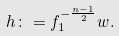<formula> <loc_0><loc_0><loc_500><loc_500>h \colon = f _ { 1 } ^ { - \frac { n - 1 } { 2 } } w .</formula> 